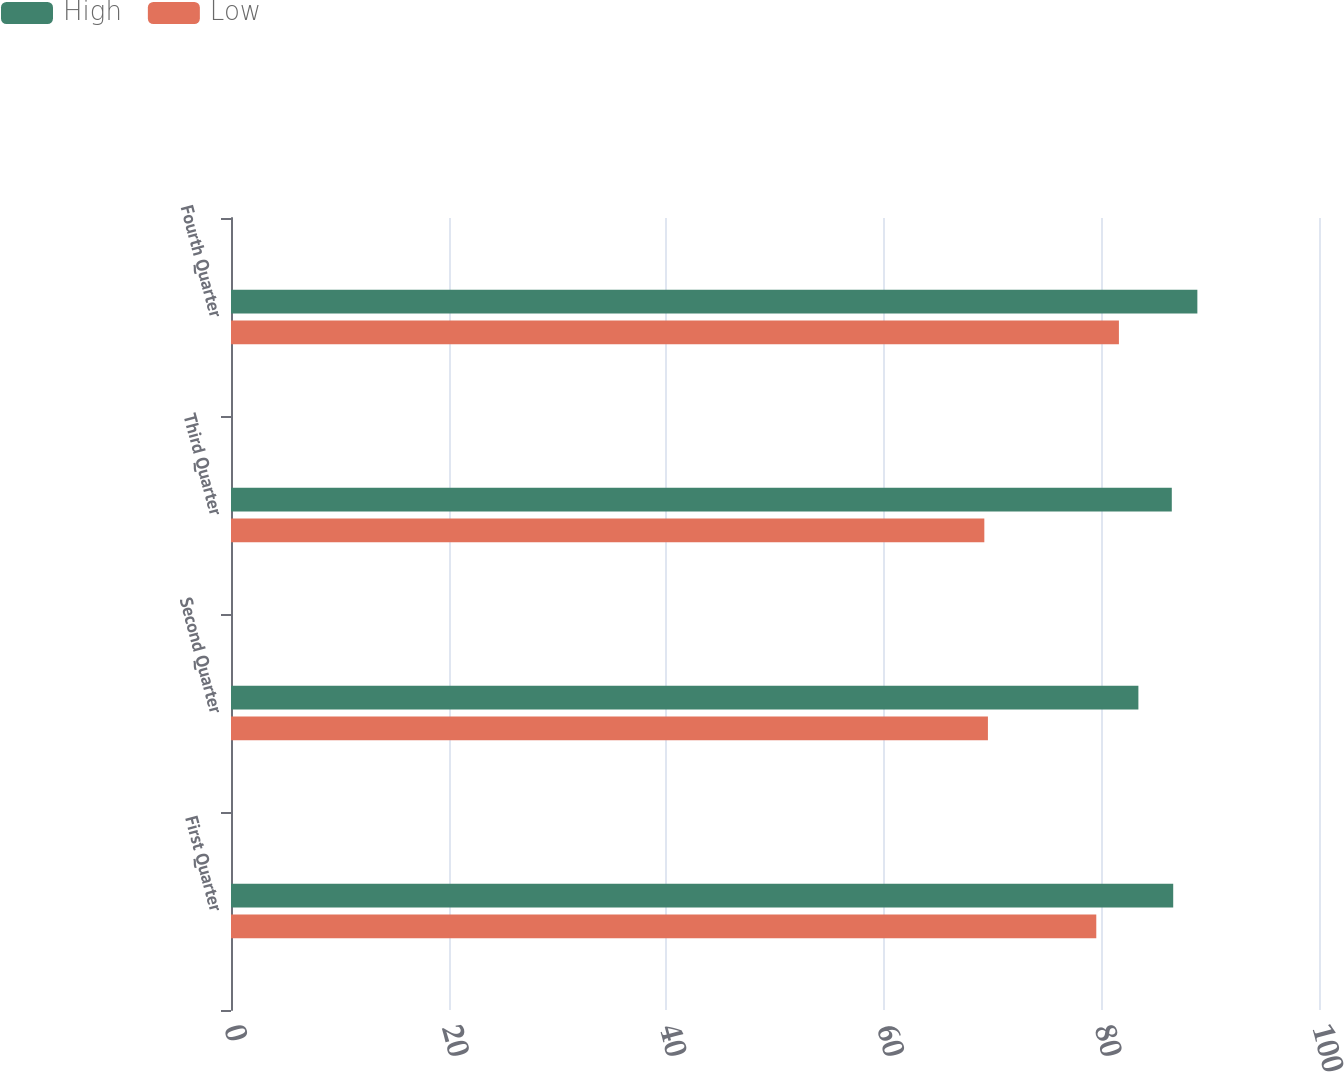Convert chart. <chart><loc_0><loc_0><loc_500><loc_500><stacked_bar_chart><ecel><fcel>First Quarter<fcel>Second Quarter<fcel>Third Quarter<fcel>Fourth Quarter<nl><fcel>High<fcel>86.6<fcel>83.4<fcel>86.47<fcel>88.82<nl><fcel>Low<fcel>79.53<fcel>69.57<fcel>69.24<fcel>81.61<nl></chart> 